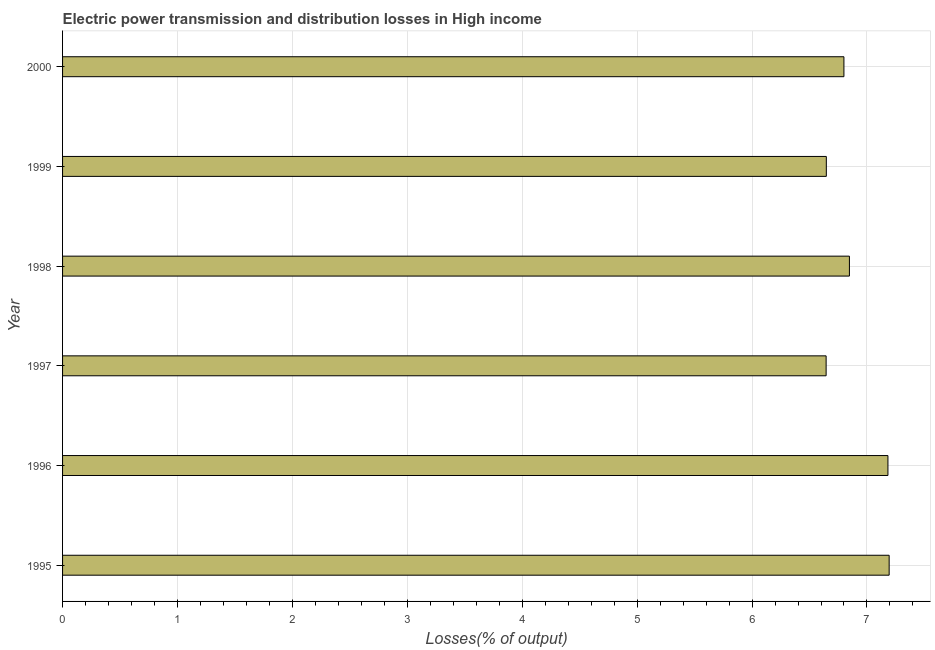What is the title of the graph?
Give a very brief answer. Electric power transmission and distribution losses in High income. What is the label or title of the X-axis?
Offer a terse response. Losses(% of output). What is the label or title of the Y-axis?
Offer a terse response. Year. What is the electric power transmission and distribution losses in 1998?
Keep it short and to the point. 6.85. Across all years, what is the maximum electric power transmission and distribution losses?
Your response must be concise. 7.19. Across all years, what is the minimum electric power transmission and distribution losses?
Your answer should be very brief. 6.64. In which year was the electric power transmission and distribution losses minimum?
Your answer should be compact. 1997. What is the sum of the electric power transmission and distribution losses?
Offer a very short reply. 41.31. What is the difference between the electric power transmission and distribution losses in 1997 and 1998?
Provide a short and direct response. -0.2. What is the average electric power transmission and distribution losses per year?
Offer a very short reply. 6.89. What is the median electric power transmission and distribution losses?
Offer a terse response. 6.82. In how many years, is the electric power transmission and distribution losses greater than 6.8 %?
Give a very brief answer. 3. Do a majority of the years between 2000 and 1997 (inclusive) have electric power transmission and distribution losses greater than 6 %?
Provide a succinct answer. Yes. Is the electric power transmission and distribution losses in 1995 less than that in 2000?
Make the answer very short. No. Is the difference between the electric power transmission and distribution losses in 1997 and 1998 greater than the difference between any two years?
Your response must be concise. No. What is the difference between the highest and the second highest electric power transmission and distribution losses?
Provide a succinct answer. 0.01. Is the sum of the electric power transmission and distribution losses in 1995 and 1999 greater than the maximum electric power transmission and distribution losses across all years?
Keep it short and to the point. Yes. What is the difference between the highest and the lowest electric power transmission and distribution losses?
Make the answer very short. 0.55. How many bars are there?
Provide a short and direct response. 6. Are all the bars in the graph horizontal?
Provide a short and direct response. Yes. How many years are there in the graph?
Your answer should be compact. 6. What is the difference between two consecutive major ticks on the X-axis?
Your answer should be compact. 1. Are the values on the major ticks of X-axis written in scientific E-notation?
Provide a succinct answer. No. What is the Losses(% of output) in 1995?
Offer a very short reply. 7.19. What is the Losses(% of output) of 1996?
Provide a short and direct response. 7.18. What is the Losses(% of output) in 1997?
Offer a very short reply. 6.64. What is the Losses(% of output) in 1998?
Your answer should be very brief. 6.85. What is the Losses(% of output) of 1999?
Your answer should be very brief. 6.65. What is the Losses(% of output) of 2000?
Give a very brief answer. 6.8. What is the difference between the Losses(% of output) in 1995 and 1996?
Offer a very short reply. 0.01. What is the difference between the Losses(% of output) in 1995 and 1997?
Provide a succinct answer. 0.55. What is the difference between the Losses(% of output) in 1995 and 1998?
Your answer should be compact. 0.35. What is the difference between the Losses(% of output) in 1995 and 1999?
Provide a short and direct response. 0.55. What is the difference between the Losses(% of output) in 1995 and 2000?
Offer a very short reply. 0.39. What is the difference between the Losses(% of output) in 1996 and 1997?
Your response must be concise. 0.54. What is the difference between the Losses(% of output) in 1996 and 1998?
Offer a very short reply. 0.34. What is the difference between the Losses(% of output) in 1996 and 1999?
Your response must be concise. 0.54. What is the difference between the Losses(% of output) in 1996 and 2000?
Your response must be concise. 0.38. What is the difference between the Losses(% of output) in 1997 and 1998?
Give a very brief answer. -0.2. What is the difference between the Losses(% of output) in 1997 and 1999?
Keep it short and to the point. -0. What is the difference between the Losses(% of output) in 1997 and 2000?
Give a very brief answer. -0.15. What is the difference between the Losses(% of output) in 1998 and 1999?
Offer a terse response. 0.2. What is the difference between the Losses(% of output) in 1998 and 2000?
Your response must be concise. 0.05. What is the difference between the Losses(% of output) in 1999 and 2000?
Give a very brief answer. -0.15. What is the ratio of the Losses(% of output) in 1995 to that in 1996?
Give a very brief answer. 1. What is the ratio of the Losses(% of output) in 1995 to that in 1997?
Make the answer very short. 1.08. What is the ratio of the Losses(% of output) in 1995 to that in 1998?
Give a very brief answer. 1.05. What is the ratio of the Losses(% of output) in 1995 to that in 1999?
Make the answer very short. 1.08. What is the ratio of the Losses(% of output) in 1995 to that in 2000?
Provide a short and direct response. 1.06. What is the ratio of the Losses(% of output) in 1996 to that in 1997?
Make the answer very short. 1.08. What is the ratio of the Losses(% of output) in 1996 to that in 1998?
Offer a terse response. 1.05. What is the ratio of the Losses(% of output) in 1996 to that in 1999?
Offer a very short reply. 1.08. What is the ratio of the Losses(% of output) in 1996 to that in 2000?
Provide a short and direct response. 1.06. What is the ratio of the Losses(% of output) in 1997 to that in 2000?
Provide a short and direct response. 0.98. What is the ratio of the Losses(% of output) in 1998 to that in 2000?
Offer a terse response. 1.01. 